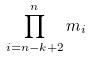Convert formula to latex. <formula><loc_0><loc_0><loc_500><loc_500>\prod _ { i = n - k + 2 } ^ { n } m _ { i }</formula> 